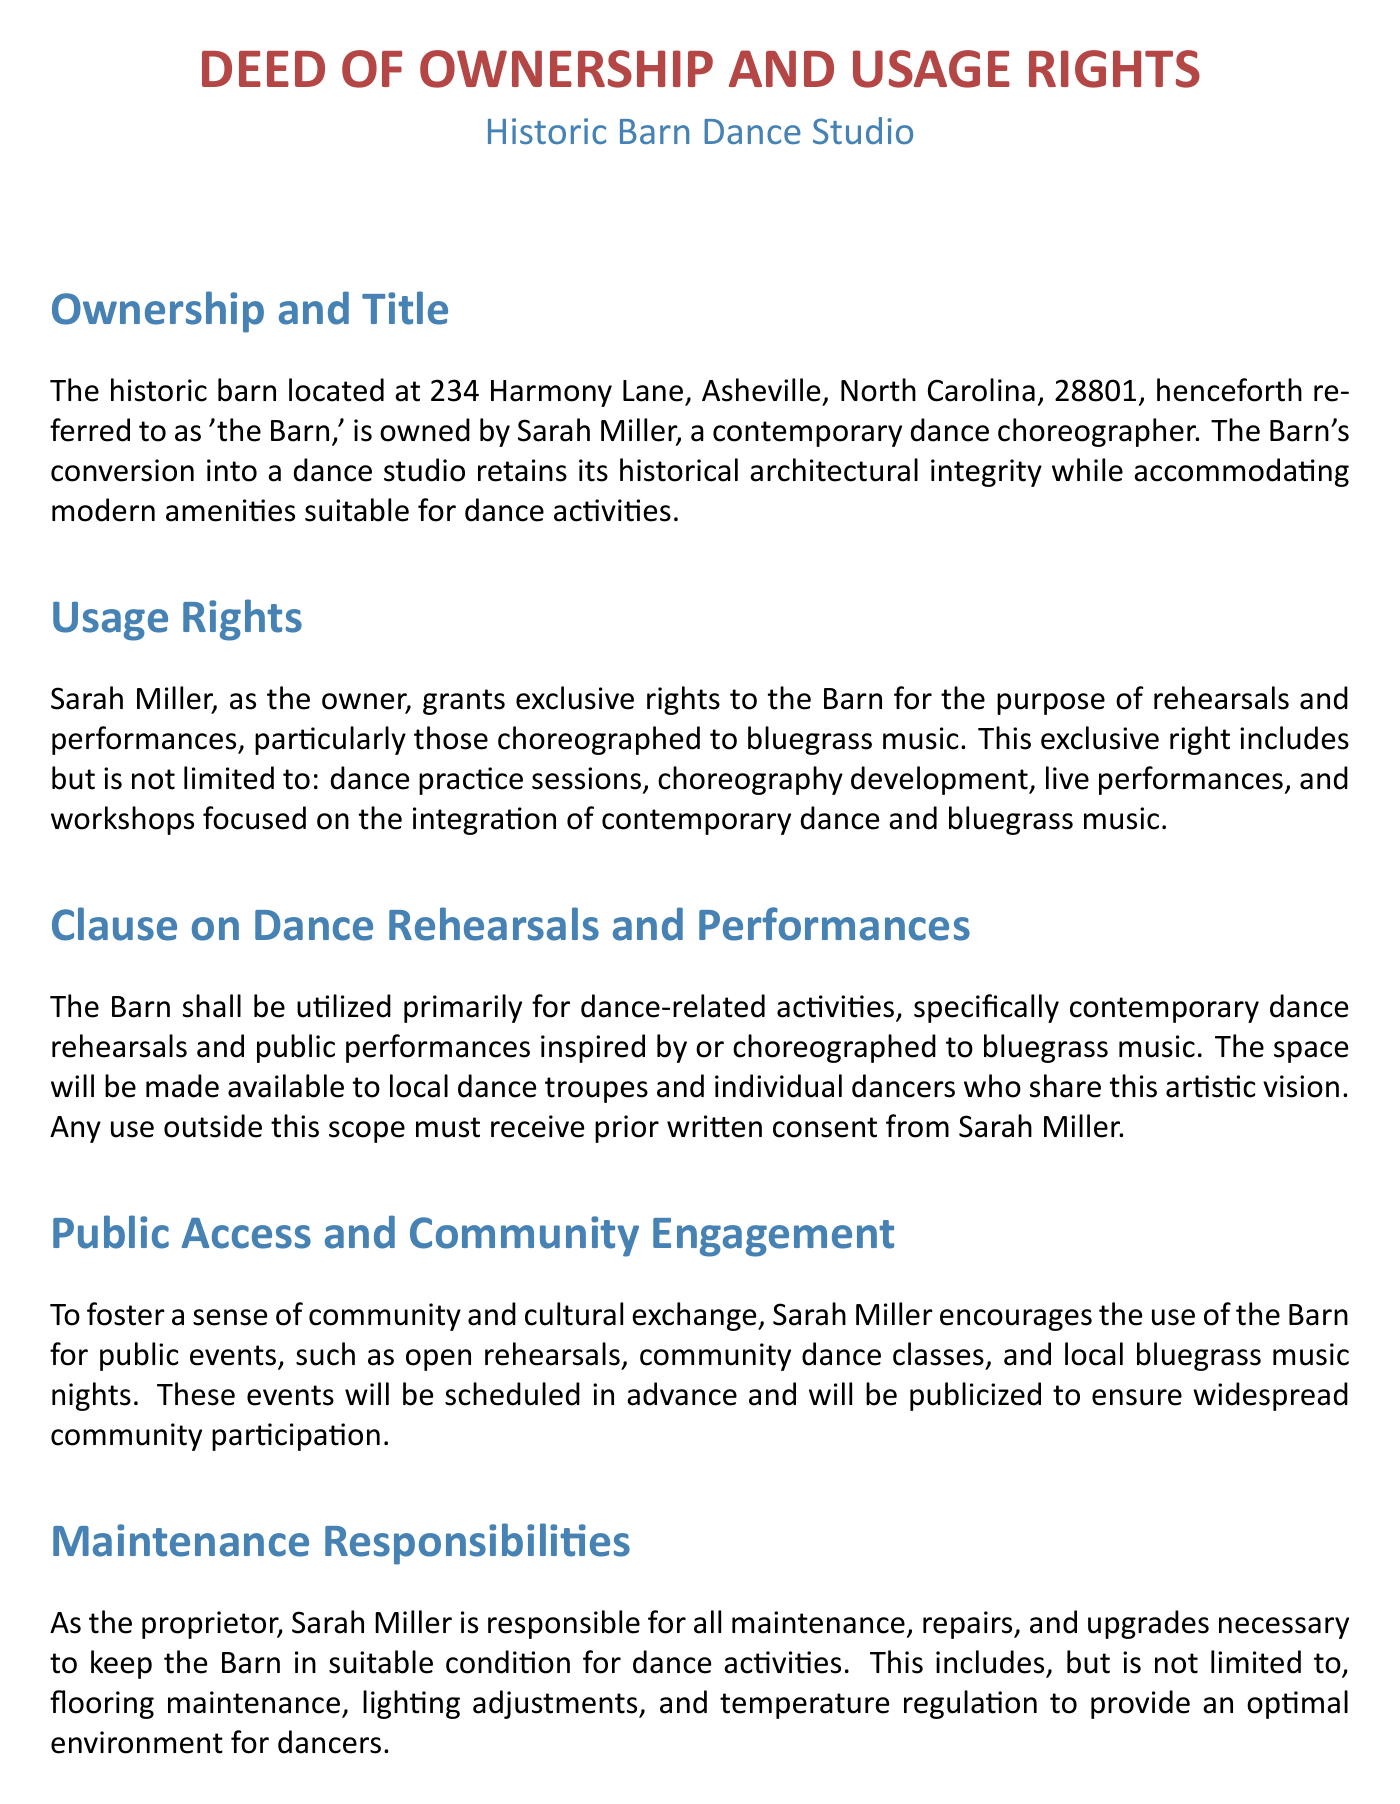what is the address of the Barn? The address is provided in the Ownership and Title section of the document.
Answer: 234 Harmony Lane, Asheville, North Carolina, 28801 who is the owner of the Barn? The owner is mentioned at the beginning of the document.
Answer: Sarah Miller for what purpose is the Barn primarily used? The purpose of use is stated clearly in the Clause on Dance Rehearsals and Performances section.
Answer: dance-related activities what type of music is emphasized for performances in the Barn? The specific genre of music is highlighted in the Usage Rights section.
Answer: bluegrass music what is Sarah Miller responsible for regarding the Barn? The responsibilities of Sarah Miller are detailed in the Maintenance Responsibilities section.
Answer: maintenance, repairs, and upgrades what type of events does Sarah Miller encourage at the Barn? The community engagement initiatives are described in the Public Access and Community Engagement section.
Answer: public events what must participants sign to release Sarah Miller from liability? The document indicates a specific requirement for participants in the Insurance and Liability section.
Answer: a waiver which state's laws govern this Deed? The governing law is stated towards the end of the document.
Answer: North Carolina 